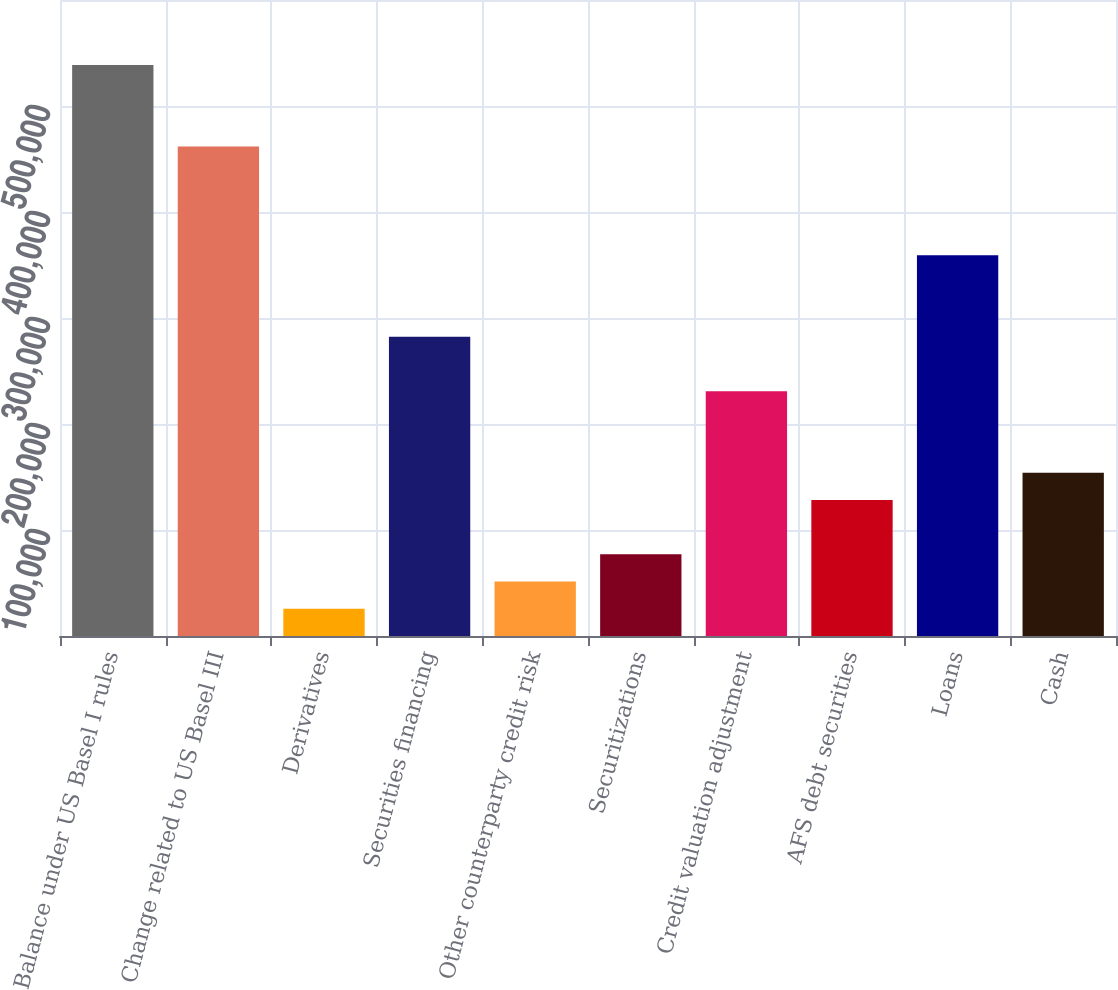Convert chart. <chart><loc_0><loc_0><loc_500><loc_500><bar_chart><fcel>Balance under US Basel I rules<fcel>Change related to US Basel III<fcel>Derivatives<fcel>Securities financing<fcel>Other counterparty credit risk<fcel>Securitizations<fcel>Credit valuation adjustment<fcel>AFS debt securities<fcel>Loans<fcel>Cash<nl><fcel>538708<fcel>461771<fcel>25795.6<fcel>282252<fcel>51441.2<fcel>77086.8<fcel>230960<fcel>128378<fcel>359188<fcel>154024<nl></chart> 